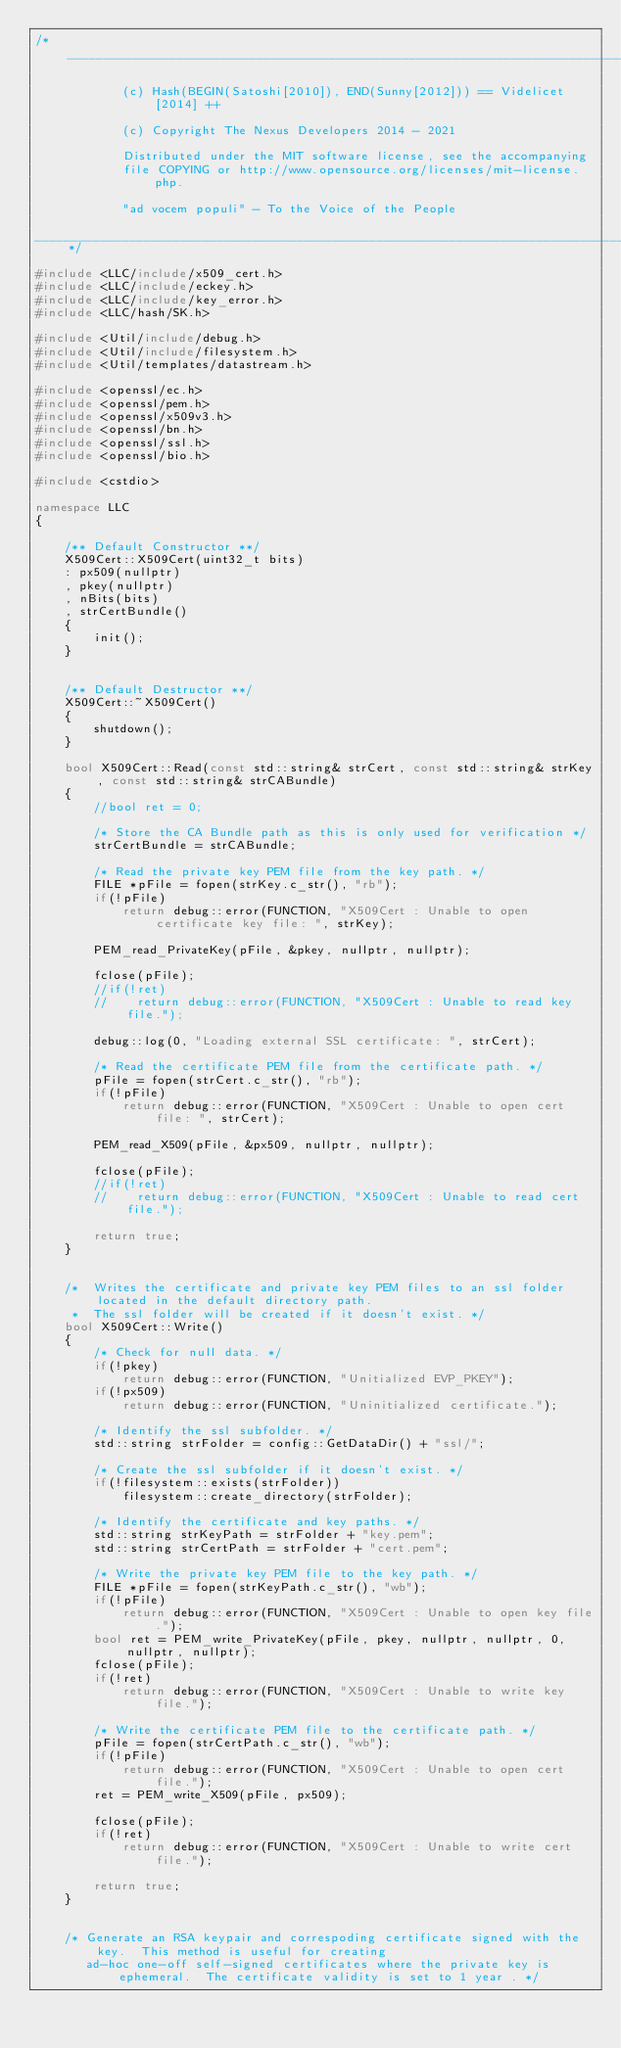<code> <loc_0><loc_0><loc_500><loc_500><_C++_>/*__________________________________________________________________________________________

            (c) Hash(BEGIN(Satoshi[2010]), END(Sunny[2012])) == Videlicet[2014] ++

            (c) Copyright The Nexus Developers 2014 - 2021

            Distributed under the MIT software license, see the accompanying
            file COPYING or http://www.opensource.org/licenses/mit-license.php.

            "ad vocem populi" - To the Voice of the People

____________________________________________________________________________________________*/

#include <LLC/include/x509_cert.h>
#include <LLC/include/eckey.h>
#include <LLC/include/key_error.h>
#include <LLC/hash/SK.h>

#include <Util/include/debug.h>
#include <Util/include/filesystem.h>
#include <Util/templates/datastream.h>

#include <openssl/ec.h> 
#include <openssl/pem.h>
#include <openssl/x509v3.h>
#include <openssl/bn.h>
#include <openssl/ssl.h>
#include <openssl/bio.h>

#include <cstdio>

namespace LLC
{

    /** Default Constructor **/
    X509Cert::X509Cert(uint32_t bits)
    : px509(nullptr)
    , pkey(nullptr)
    , nBits(bits)
    , strCertBundle()
    {
        init();
    }


    /** Default Destructor **/
    X509Cert::~X509Cert()
    {
        shutdown();
    }

    bool X509Cert::Read(const std::string& strCert, const std::string& strKey, const std::string& strCABundle)
    {
        //bool ret = 0;

        /* Store the CA Bundle path as this is only used for verification */
        strCertBundle = strCABundle;

        /* Read the private key PEM file from the key path. */
        FILE *pFile = fopen(strKey.c_str(), "rb");
        if(!pFile)
            return debug::error(FUNCTION, "X509Cert : Unable to open certificate key file: ", strKey);

        PEM_read_PrivateKey(pFile, &pkey, nullptr, nullptr);

        fclose(pFile);
        //if(!ret)
        //    return debug::error(FUNCTION, "X509Cert : Unable to read key file.");

        debug::log(0, "Loading external SSL certificate: ", strCert);

        /* Read the certificate PEM file from the certificate path. */
        pFile = fopen(strCert.c_str(), "rb");
        if(!pFile)
            return debug::error(FUNCTION, "X509Cert : Unable to open cert file: ", strCert);

        PEM_read_X509(pFile, &px509, nullptr, nullptr);

        fclose(pFile);
        //if(!ret)
        //    return debug::error(FUNCTION, "X509Cert : Unable to read cert file.");

        return true;
    }


    /*  Writes the certificate and private key PEM files to an ssl folder located in the default directory path.
     *  The ssl folder will be created if it doesn't exist. */
    bool X509Cert::Write()
    {
        /* Check for null data. */
        if(!pkey)
            return debug::error(FUNCTION, "Unitialized EVP_PKEY");
        if(!px509)
            return debug::error(FUNCTION, "Uninitialized certificate.");

        /* Identify the ssl subfolder. */
        std::string strFolder = config::GetDataDir() + "ssl/";

        /* Create the ssl subfolder if it doesn't exist. */
        if(!filesystem::exists(strFolder))
            filesystem::create_directory(strFolder);

        /* Identify the certificate and key paths. */
        std::string strKeyPath = strFolder + "key.pem";
        std::string strCertPath = strFolder + "cert.pem";

        /* Write the private key PEM file to the key path. */
        FILE *pFile = fopen(strKeyPath.c_str(), "wb");
        if(!pFile)
            return debug::error(FUNCTION, "X509Cert : Unable to open key file.");
        bool ret = PEM_write_PrivateKey(pFile, pkey, nullptr, nullptr, 0, nullptr, nullptr);
        fclose(pFile);
        if(!ret)
            return debug::error(FUNCTION, "X509Cert : Unable to write key file.");

        /* Write the certificate PEM file to the certificate path. */
        pFile = fopen(strCertPath.c_str(), "wb");
        if(!pFile)
            return debug::error(FUNCTION, "X509Cert : Unable to open cert file.");
        ret = PEM_write_X509(pFile, px509);
        
        fclose(pFile);
        if(!ret)
            return debug::error(FUNCTION, "X509Cert : Unable to write cert file.");

        return true;
    }


    /* Generate an RSA keypair and correspoding certificate signed with the key.  This method is useful for creating
       ad-hoc one-off self-signed certificates where the private key is ephemeral.  The certificate validity is set to 1 year . */</code> 